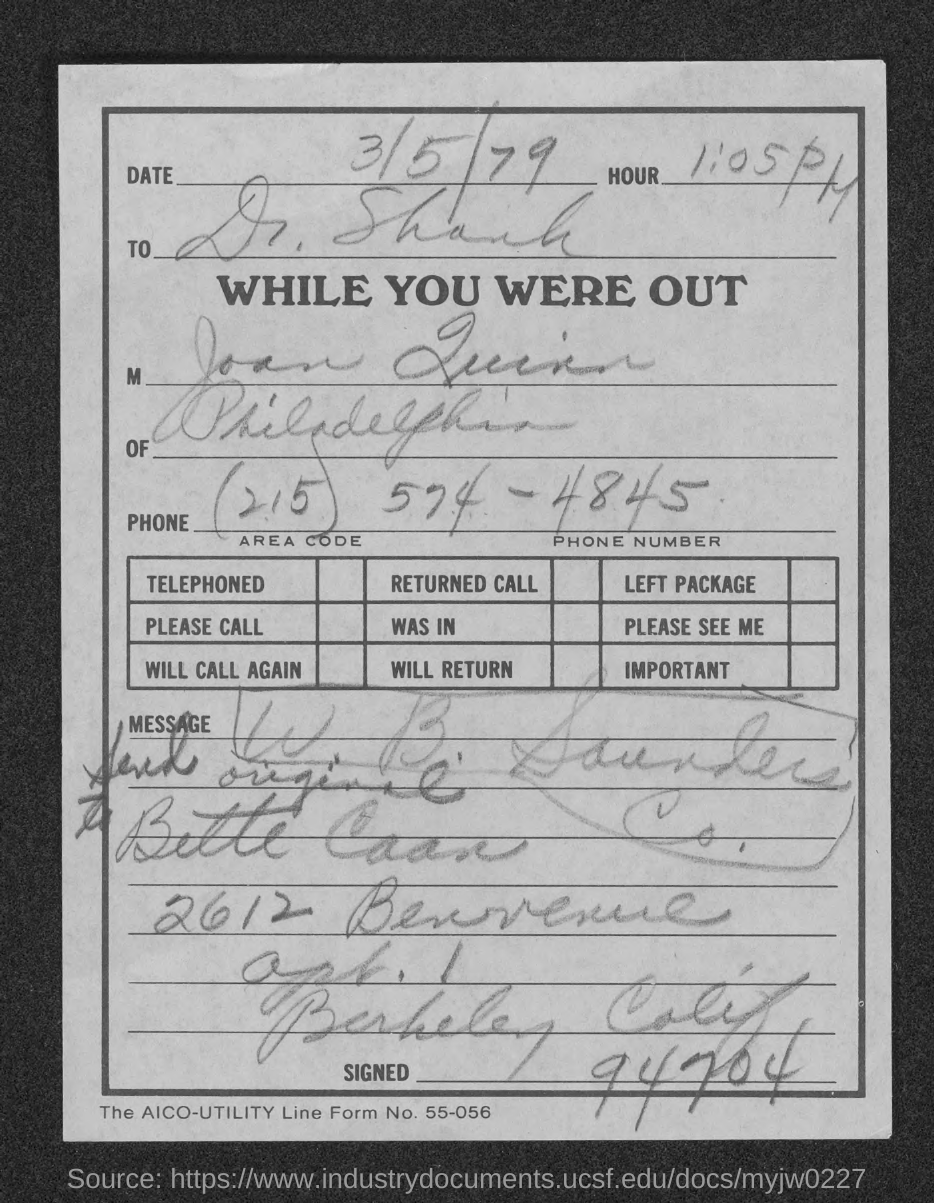Specify some key components in this picture. The time indicated in the document is 1:05 PM. The document is addressed to Dr. Shank. The date mentioned in this document is March 5, 1979. 